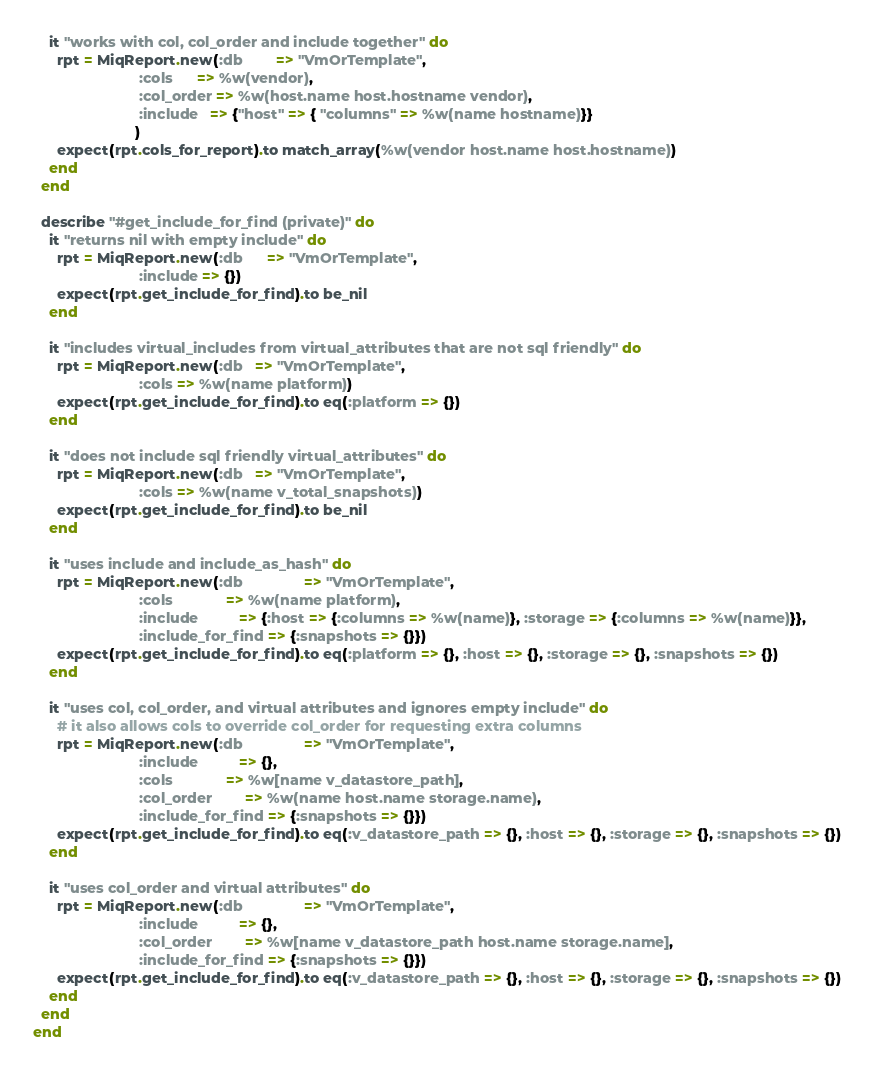Convert code to text. <code><loc_0><loc_0><loc_500><loc_500><_Ruby_>
    it "works with col, col_order and include together" do
      rpt = MiqReport.new(:db        => "VmOrTemplate",
                          :cols      => %w(vendor),
                          :col_order => %w(host.name host.hostname vendor),
                          :include   => {"host" => { "columns" => %w(name hostname)}}
                         )
      expect(rpt.cols_for_report).to match_array(%w(vendor host.name host.hostname))
    end
  end

  describe "#get_include_for_find (private)" do
    it "returns nil with empty include" do
      rpt = MiqReport.new(:db      => "VmOrTemplate",
                          :include => {})
      expect(rpt.get_include_for_find).to be_nil
    end

    it "includes virtual_includes from virtual_attributes that are not sql friendly" do
      rpt = MiqReport.new(:db   => "VmOrTemplate",
                          :cols => %w(name platform))
      expect(rpt.get_include_for_find).to eq(:platform => {})
    end

    it "does not include sql friendly virtual_attributes" do
      rpt = MiqReport.new(:db   => "VmOrTemplate",
                          :cols => %w(name v_total_snapshots))
      expect(rpt.get_include_for_find).to be_nil
    end

    it "uses include and include_as_hash" do
      rpt = MiqReport.new(:db               => "VmOrTemplate",
                          :cols             => %w(name platform),
                          :include          => {:host => {:columns => %w(name)}, :storage => {:columns => %w(name)}},
                          :include_for_find => {:snapshots => {}})
      expect(rpt.get_include_for_find).to eq(:platform => {}, :host => {}, :storage => {}, :snapshots => {})
    end

    it "uses col, col_order, and virtual attributes and ignores empty include" do
      # it also allows cols to override col_order for requesting extra columns
      rpt = MiqReport.new(:db               => "VmOrTemplate",
                          :include          => {},
                          :cols             => %w[name v_datastore_path],
                          :col_order        => %w(name host.name storage.name),
                          :include_for_find => {:snapshots => {}})
      expect(rpt.get_include_for_find).to eq(:v_datastore_path => {}, :host => {}, :storage => {}, :snapshots => {})
    end

    it "uses col_order and virtual attributes" do
      rpt = MiqReport.new(:db               => "VmOrTemplate",
                          :include          => {},
                          :col_order        => %w[name v_datastore_path host.name storage.name],
                          :include_for_find => {:snapshots => {}})
      expect(rpt.get_include_for_find).to eq(:v_datastore_path => {}, :host => {}, :storage => {}, :snapshots => {})
    end
  end
end
</code> 